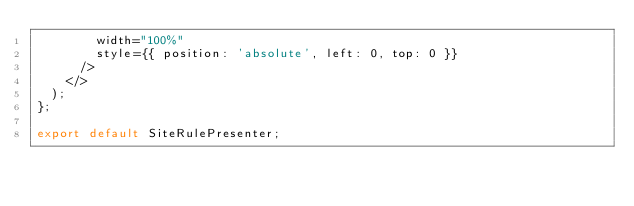<code> <loc_0><loc_0><loc_500><loc_500><_JavaScript_>        width="100%"
        style={{ position: 'absolute', left: 0, top: 0 }}
      />
    </>
  );
};

export default SiteRulePresenter;
</code> 